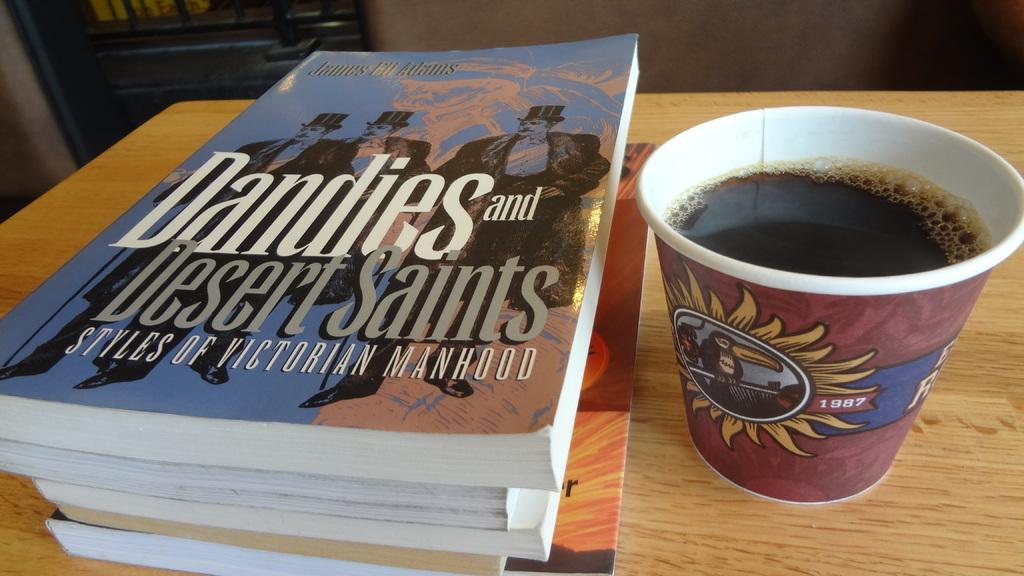Provide a one-sentence caption for the provided image. Cup of coffee next to a book named "Dandies and Desert Saints". 